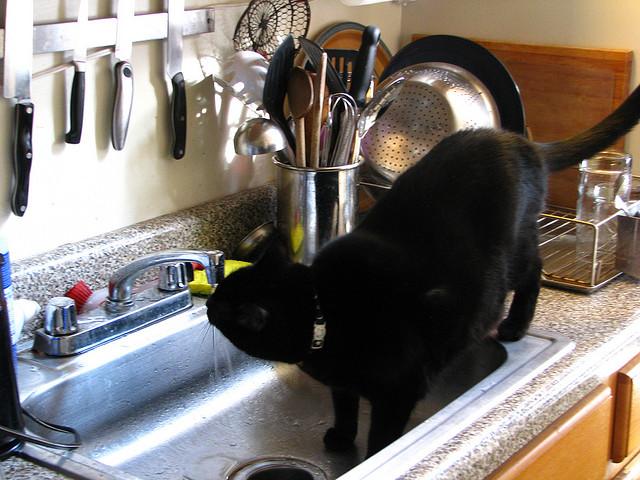Why is the cat in the sink?
Short answer required. Drinking water. How are the knives held up?
Be succinct. Magnet. What is the sink made of?
Answer briefly. Steel. 